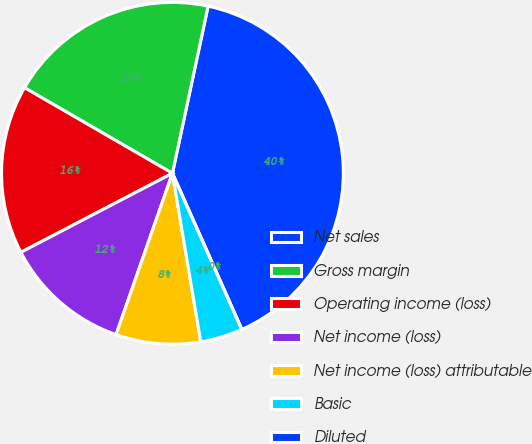<chart> <loc_0><loc_0><loc_500><loc_500><pie_chart><fcel>Net sales<fcel>Gross margin<fcel>Operating income (loss)<fcel>Net income (loss)<fcel>Net income (loss) attributable<fcel>Basic<fcel>Diluted<nl><fcel>40.0%<fcel>20.0%<fcel>16.0%<fcel>12.0%<fcel>8.0%<fcel>4.0%<fcel>0.0%<nl></chart> 